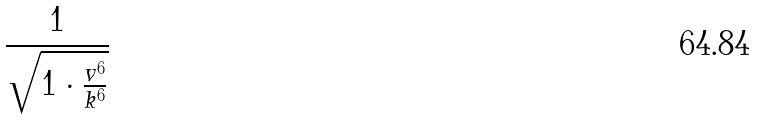Convert formula to latex. <formula><loc_0><loc_0><loc_500><loc_500>\frac { 1 } { \sqrt { 1 \cdot \frac { v ^ { 6 } } { k ^ { 6 } } } }</formula> 